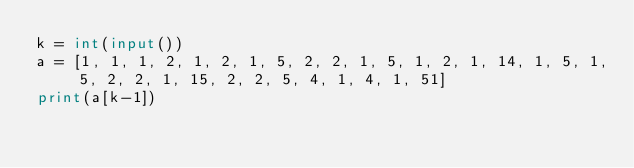Convert code to text. <code><loc_0><loc_0><loc_500><loc_500><_Python_>k = int(input())
a = [1, 1, 1, 2, 1, 2, 1, 5, 2, 2, 1, 5, 1, 2, 1, 14, 1, 5, 1, 5, 2, 2, 1, 15, 2, 2, 5, 4, 1, 4, 1, 51]
print(a[k-1])
</code> 